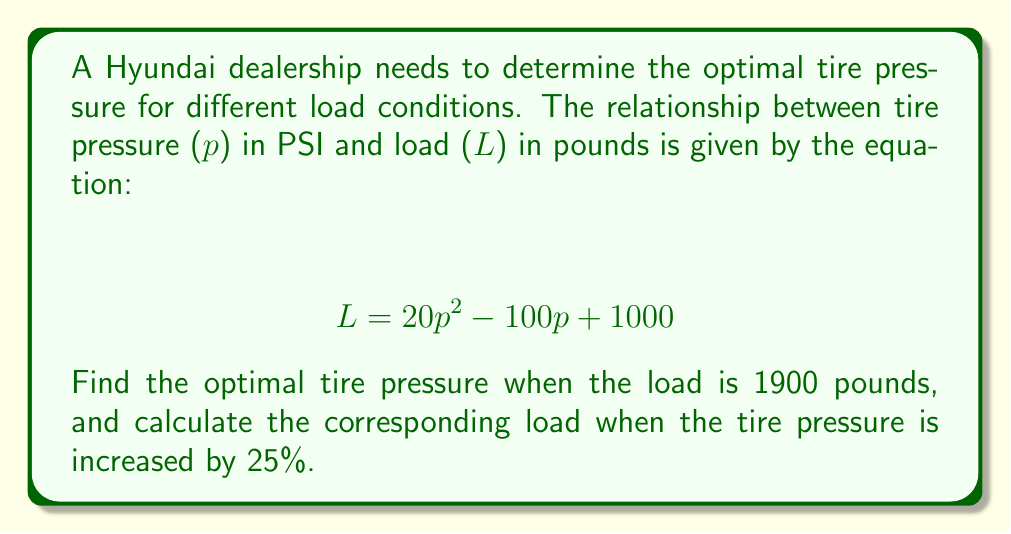Can you solve this math problem? Let's approach this problem step by step:

1. Find the optimal tire pressure for a 1900-pound load:
   Substitute $L = 1900$ into the equation:
   $$ 1900 = 20p^2 - 100p + 1000 $$
   
   Rearrange the equation:
   $$ 20p^2 - 100p - 900 = 0 $$
   
   This is a quadratic equation. Let's solve it using the quadratic formula:
   $$ p = \frac{-b \pm \sqrt{b^2 - 4ac}}{2a} $$
   
   Where $a = 20$, $b = -100$, and $c = -900$
   
   $$ p = \frac{100 \pm \sqrt{(-100)^2 - 4(20)(-900)}}{2(20)} $$
   $$ p = \frac{100 \pm \sqrt{10000 + 72000}}{40} $$
   $$ p = \frac{100 \pm \sqrt{82000}}{40} $$
   $$ p = \frac{100 \pm 286.36}{40} $$
   
   This gives us two solutions:
   $$ p_1 = \frac{100 + 286.36}{40} = 9.66 \text{ PSI} $$
   $$ p_2 = \frac{100 - 286.36}{40} = -4.66 \text{ PSI} $$
   
   Since tire pressure can't be negative, the optimal pressure is 9.66 PSI.

2. Calculate the load when tire pressure is increased by 25%:
   New pressure = $9.66 \times 1.25 = 12.075$ PSI
   
   Substitute this into the original equation:
   $$ L = 20(12.075)^2 - 100(12.075) + 1000 $$
   $$ L = 20(145.81) - 1207.5 + 1000 $$
   $$ L = 2916.2 - 1207.5 + 1000 $$
   $$ L = 2708.7 \text{ pounds} $$
Answer: The optimal tire pressure for a 1900-pound load is 9.66 PSI. When this pressure is increased by 25% to 12.075 PSI, the corresponding load is 2708.7 pounds. 